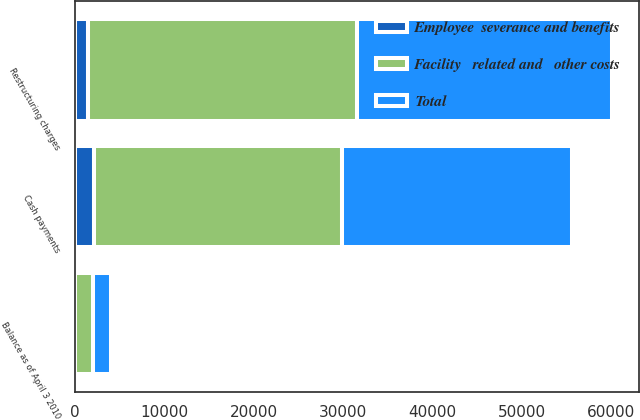Convert chart. <chart><loc_0><loc_0><loc_500><loc_500><stacked_bar_chart><ecel><fcel>Restructuring charges<fcel>Cash payments<fcel>Balance as of April 3 2010<nl><fcel>Total<fcel>28531<fcel>25633<fcel>1953<nl><fcel>Employee  severance and benefits<fcel>1533<fcel>2155<fcel>60<nl><fcel>Facility   related and   other costs<fcel>30064<fcel>27788<fcel>2013<nl></chart> 